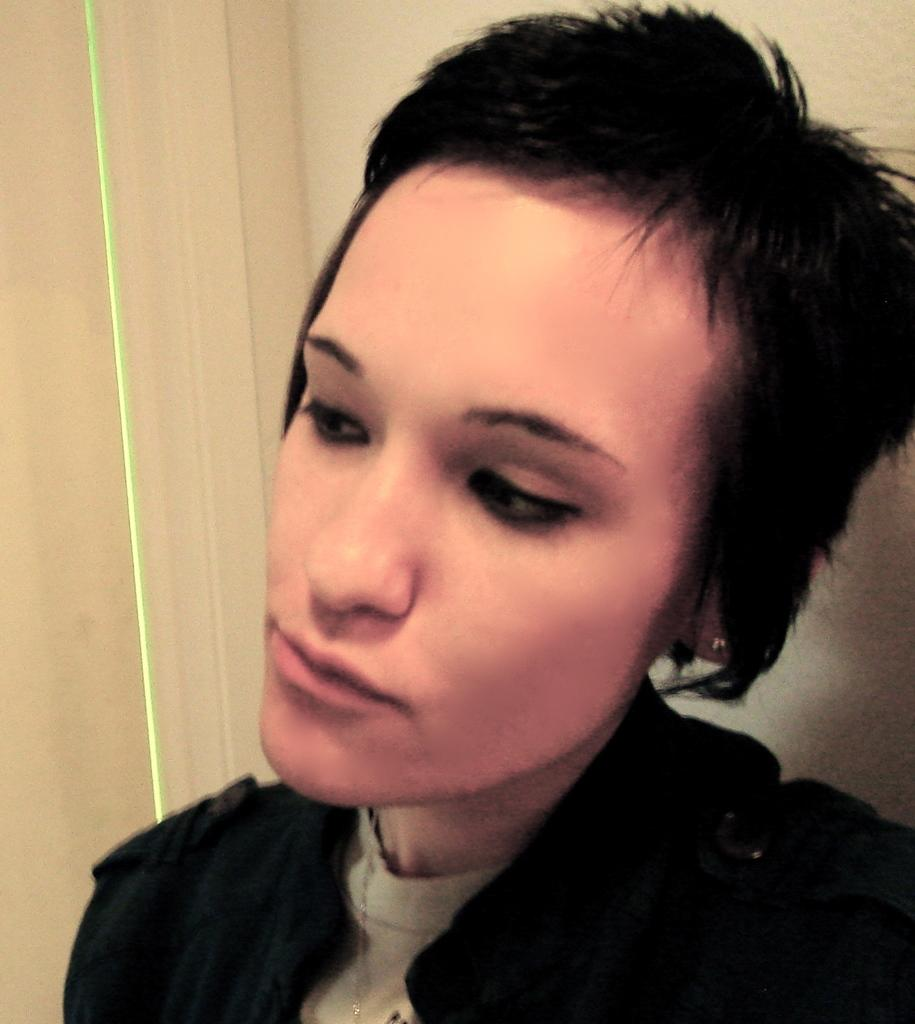Who is the main subject in the image? There is a woman in the image. What can be seen in the background of the image? There is a wall in the background of the image. What accessory is the woman wearing in the image? The woman is wearing a chain around her neck. How many elbows does the woman have in the image? The number of elbows cannot be determined from the image, as it only shows the woman's neck and the chain she is wearing. 